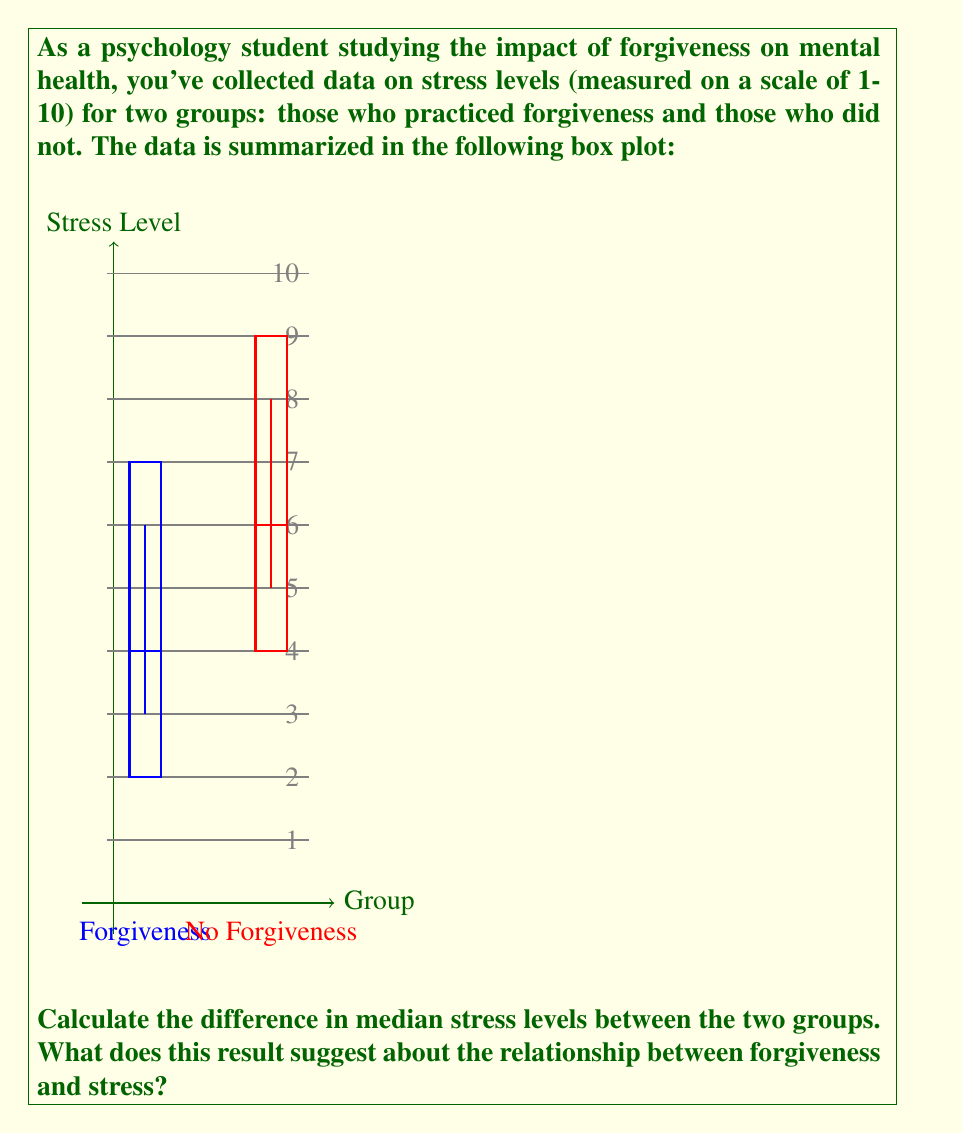Help me with this question. To solve this problem, we need to:

1. Identify the median stress level for each group from the box plot.
2. Calculate the difference between these medians.
3. Interpret the result in the context of forgiveness and stress.

Step 1: Identifying medians
- In a box plot, the median is represented by the line inside the box.
- For the Forgiveness group, the median line is at 4.
- For the No Forgiveness group, the median line is at 6.

Step 2: Calculating the difference
$$\text{Difference} = \text{Median}_{\text{No Forgiveness}} - \text{Median}_{\text{Forgiveness}}$$
$$\text{Difference} = 6 - 4 = 2$$

Step 3: Interpretation
The positive difference of 2 indicates that the median stress level for the No Forgiveness group is 2 points higher than the Forgiveness group on the 1-10 scale.

This suggests a potential relationship between forgiveness and lower stress levels. Those who practice forgiveness tend to have lower stress levels compared to those who do not practice forgiveness.

However, it's important to note that this is an observational study, and we cannot conclude causation from this data alone. Other factors might influence both forgiveness behavior and stress levels.
Answer: 2; suggests forgiveness may be associated with lower stress levels 